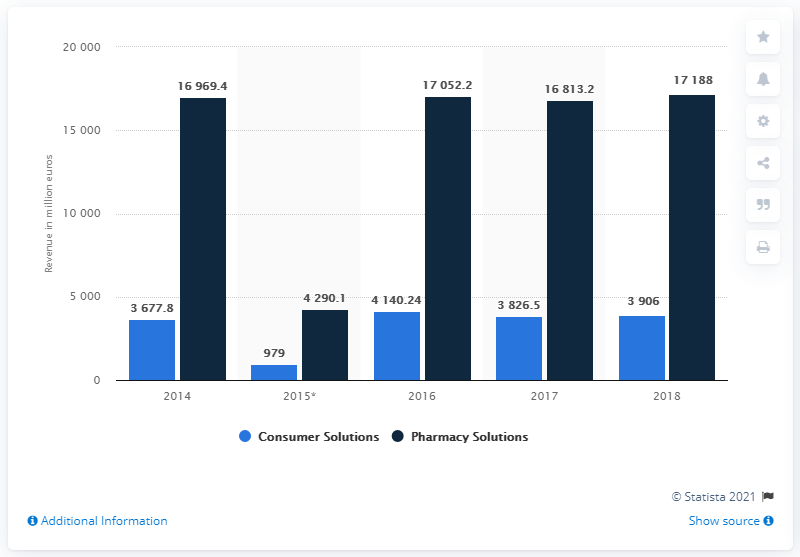Highlight a few significant elements in this photo. In Fiscal Year 2017, the pharmacy segment of McKesson Europe generated revenue of 16,813.2. 